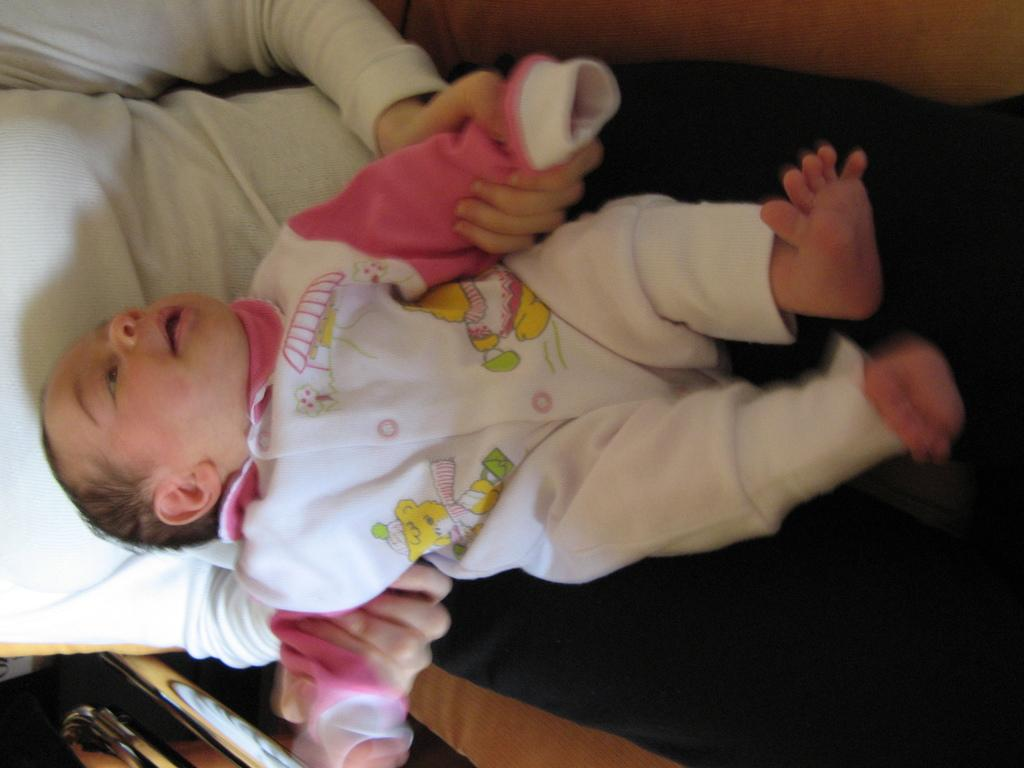What is the person in the image doing? The person is sitting in the image and holding a baby. How is the baby positioned in relation to the person? The baby is lying on the person. What can be seen at the bottom left of the image? There is an object at the bottom left of the image. What type of fowl can be seen in the background of the image? There is no fowl present in the image. What discovery was made by the person in the image? The facts provided do not mention any discovery made by the person in the image. 